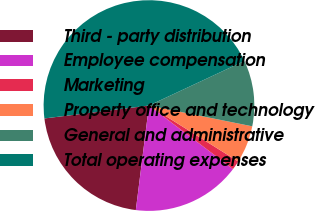<chart> <loc_0><loc_0><loc_500><loc_500><pie_chart><fcel>Third - party distribution<fcel>Employee compensation<fcel>Marketing<fcel>Property office and technology<fcel>General and administrative<fcel>Total operating expenses<nl><fcel>21.05%<fcel>16.69%<fcel>1.39%<fcel>5.75%<fcel>10.11%<fcel>44.99%<nl></chart> 